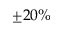<formula> <loc_0><loc_0><loc_500><loc_500>\pm 2 0 \%</formula> 